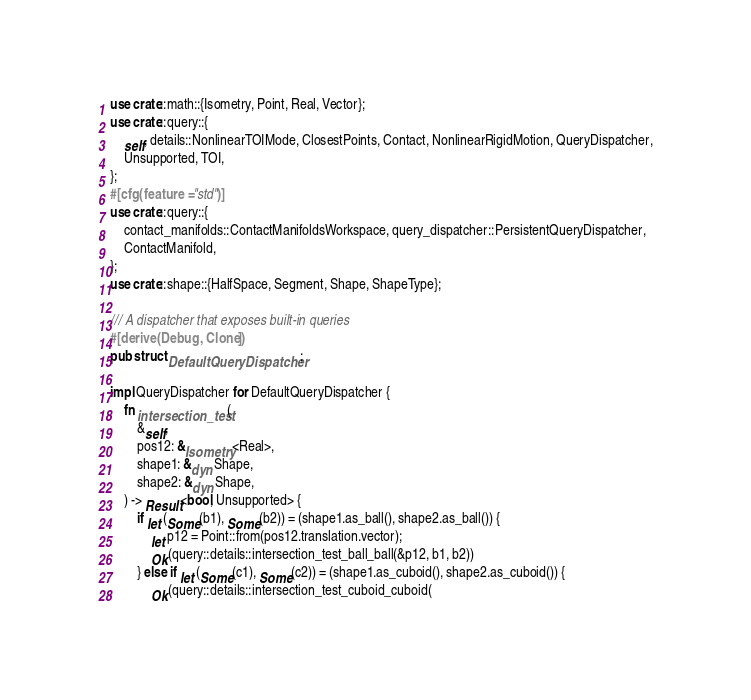<code> <loc_0><loc_0><loc_500><loc_500><_Rust_>use crate::math::{Isometry, Point, Real, Vector};
use crate::query::{
    self, details::NonlinearTOIMode, ClosestPoints, Contact, NonlinearRigidMotion, QueryDispatcher,
    Unsupported, TOI,
};
#[cfg(feature = "std")]
use crate::query::{
    contact_manifolds::ContactManifoldsWorkspace, query_dispatcher::PersistentQueryDispatcher,
    ContactManifold,
};
use crate::shape::{HalfSpace, Segment, Shape, ShapeType};

/// A dispatcher that exposes built-in queries
#[derive(Debug, Clone)]
pub struct DefaultQueryDispatcher;

impl QueryDispatcher for DefaultQueryDispatcher {
    fn intersection_test(
        &self,
        pos12: &Isometry<Real>,
        shape1: &dyn Shape,
        shape2: &dyn Shape,
    ) -> Result<bool, Unsupported> {
        if let (Some(b1), Some(b2)) = (shape1.as_ball(), shape2.as_ball()) {
            let p12 = Point::from(pos12.translation.vector);
            Ok(query::details::intersection_test_ball_ball(&p12, b1, b2))
        } else if let (Some(c1), Some(c2)) = (shape1.as_cuboid(), shape2.as_cuboid()) {
            Ok(query::details::intersection_test_cuboid_cuboid(</code> 